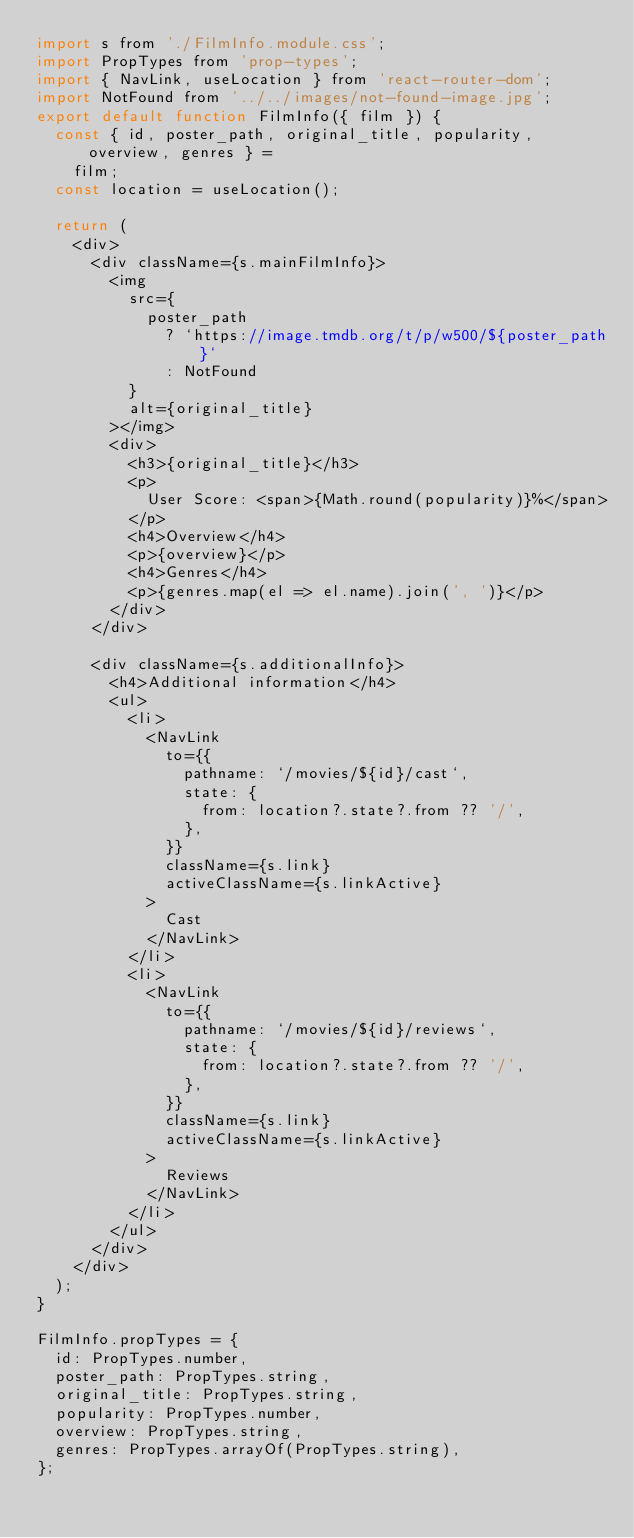Convert code to text. <code><loc_0><loc_0><loc_500><loc_500><_JavaScript_>import s from './FilmInfo.module.css';
import PropTypes from 'prop-types';
import { NavLink, useLocation } from 'react-router-dom';
import NotFound from '../../images/not-found-image.jpg';
export default function FilmInfo({ film }) {
  const { id, poster_path, original_title, popularity, overview, genres } =
    film;
  const location = useLocation();

  return (
    <div>
      <div className={s.mainFilmInfo}>
        <img
          src={
            poster_path
              ? `https://image.tmdb.org/t/p/w500/${poster_path}`
              : NotFound
          }
          alt={original_title}
        ></img>
        <div>
          <h3>{original_title}</h3>
          <p>
            User Score: <span>{Math.round(popularity)}%</span>
          </p>
          <h4>Overview</h4>
          <p>{overview}</p>
          <h4>Genres</h4>
          <p>{genres.map(el => el.name).join(', ')}</p>
        </div>
      </div>

      <div className={s.additionalInfo}>
        <h4>Additional information</h4>
        <ul>
          <li>
            <NavLink
              to={{
                pathname: `/movies/${id}/cast`,
                state: {
                  from: location?.state?.from ?? '/',
                },
              }}
              className={s.link}
              activeClassName={s.linkActive}
            >
              Cast
            </NavLink>
          </li>
          <li>
            <NavLink
              to={{
                pathname: `/movies/${id}/reviews`,
                state: {
                  from: location?.state?.from ?? '/',
                },
              }}
              className={s.link}
              activeClassName={s.linkActive}
            >
              Reviews
            </NavLink>
          </li>
        </ul>
      </div>
    </div>
  );
}

FilmInfo.propTypes = {
  id: PropTypes.number,
  poster_path: PropTypes.string,
  original_title: PropTypes.string,
  popularity: PropTypes.number,
  overview: PropTypes.string,
  genres: PropTypes.arrayOf(PropTypes.string),
};
</code> 